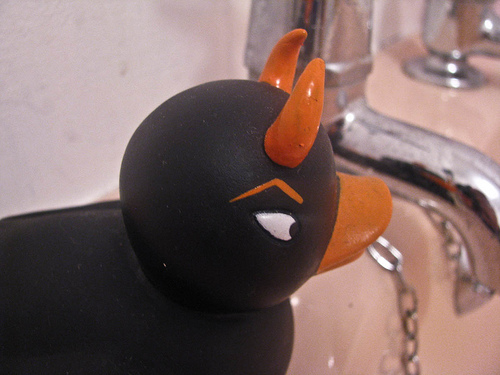<image>
Can you confirm if the bull is on the chain? Yes. Looking at the image, I can see the bull is positioned on top of the chain, with the chain providing support. Is there a horns on the duck? Yes. Looking at the image, I can see the horns is positioned on top of the duck, with the duck providing support. Is the horns on the ducky? Yes. Looking at the image, I can see the horns is positioned on top of the ducky, with the ducky providing support. 